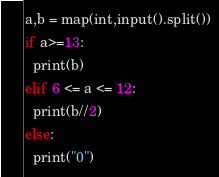<code> <loc_0><loc_0><loc_500><loc_500><_Python_>a,b = map(int,input().split())
if a>=13:
  print(b)
elif 6 <= a <= 12:
  print(b//2)
else:
  print("0")</code> 